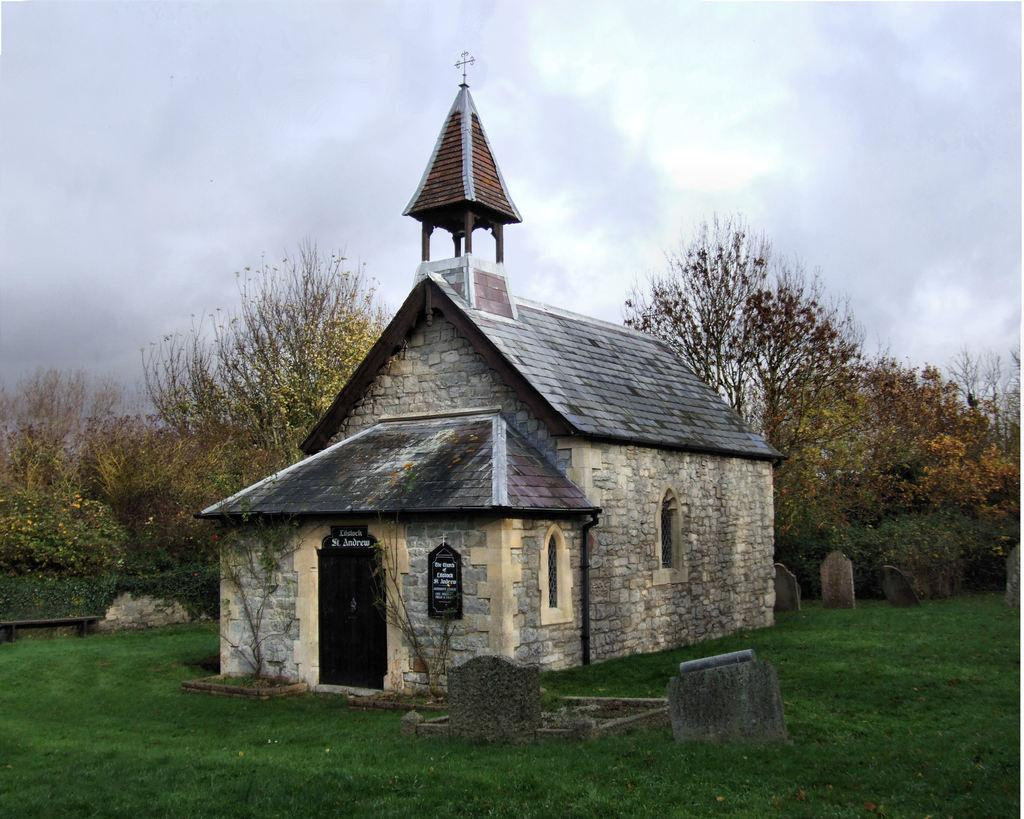What type of structure is present in the image? There is a house in the picture. What type of vegetation can be seen in the image? There is grass visible in the picture. Are there any other natural elements present in the image? Yes, there are trees in the picture. What type of apparel is the house wearing in the image? The house is not wearing any apparel, as it is a structure and not a living being. 